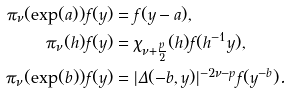<formula> <loc_0><loc_0><loc_500><loc_500>\pi _ { \nu } ( \exp ( a ) ) f ( y ) & = f ( y - a ) , \\ \pi _ { \nu } ( h ) f ( y ) & = \chi _ { \nu + \frac { p } { 2 } } ( h ) f ( h ^ { - 1 } y ) , \\ \pi _ { \nu } ( \exp ( b ) ) f ( y ) & = | \Delta ( - b , y ) | ^ { - 2 \nu - p } f ( y ^ { - b } ) .</formula> 